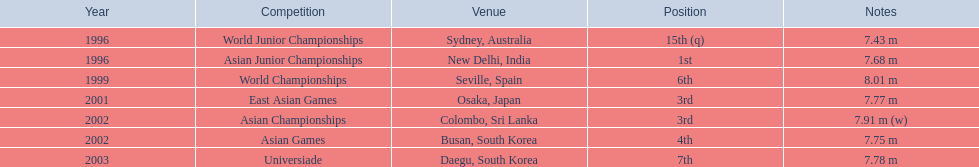What positions has the competitor attained throughout various contests? 15th (q), 1st, 6th, 3rd, 3rd, 4th, 7th. In which competition did they claim the top spot? Asian Junior Championships. 